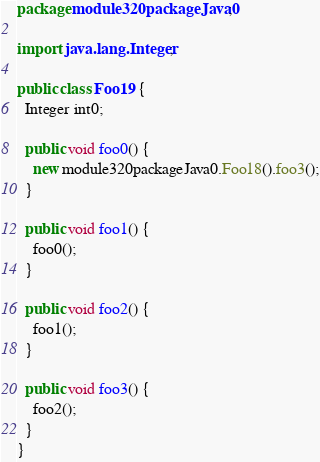Convert code to text. <code><loc_0><loc_0><loc_500><loc_500><_Java_>package module320packageJava0;

import java.lang.Integer;

public class Foo19 {
  Integer int0;

  public void foo0() {
    new module320packageJava0.Foo18().foo3();
  }

  public void foo1() {
    foo0();
  }

  public void foo2() {
    foo1();
  }

  public void foo3() {
    foo2();
  }
}
</code> 